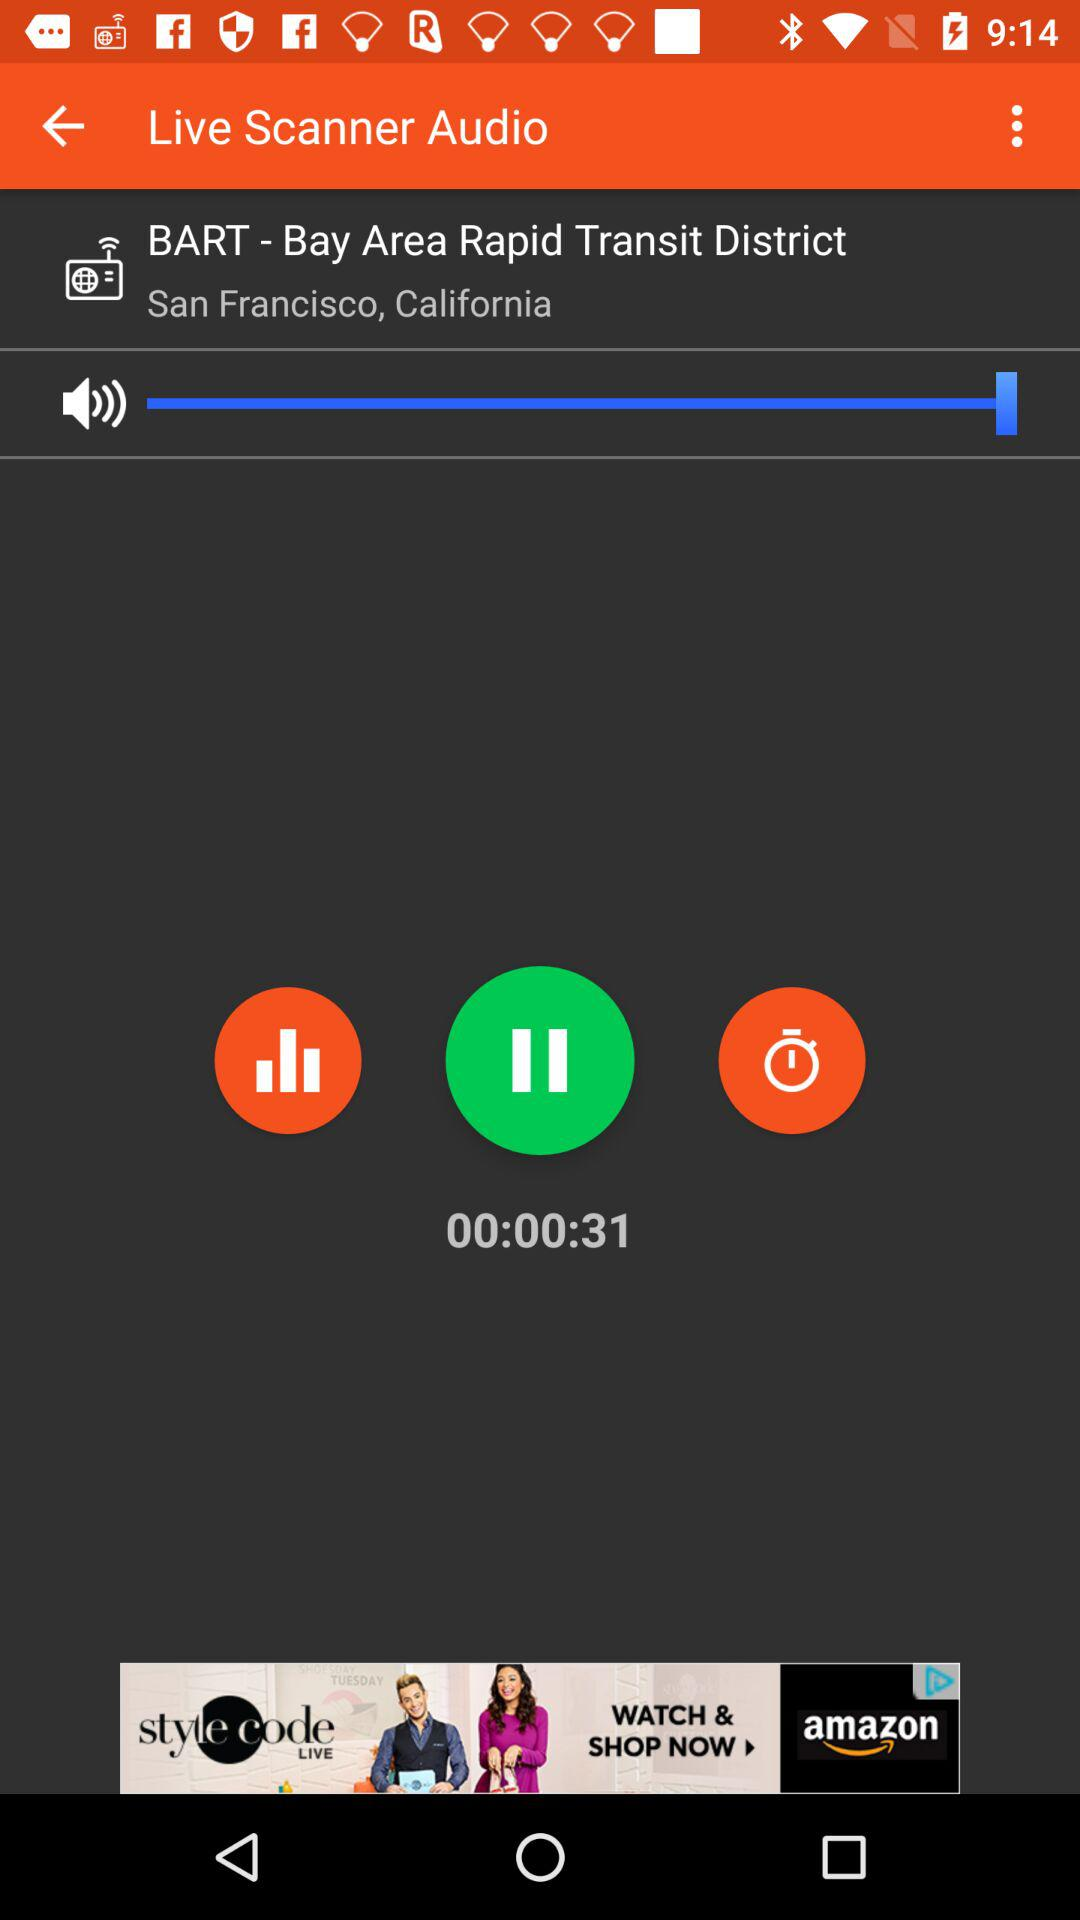What is the application name in the advertisement? The application name in the advertisement is "amazon". 